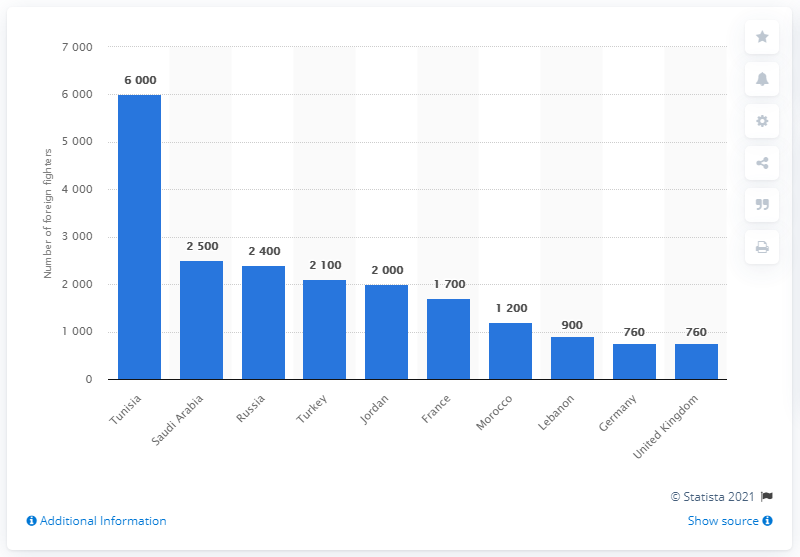Draw attention to some important aspects in this diagram. The majority of the approximately 6,000 foreign fighters who have joined groups in Syria and Iraq originated from Tunisia. Out of the approximately 760 foreign fighters, the majority originated from Germany. 